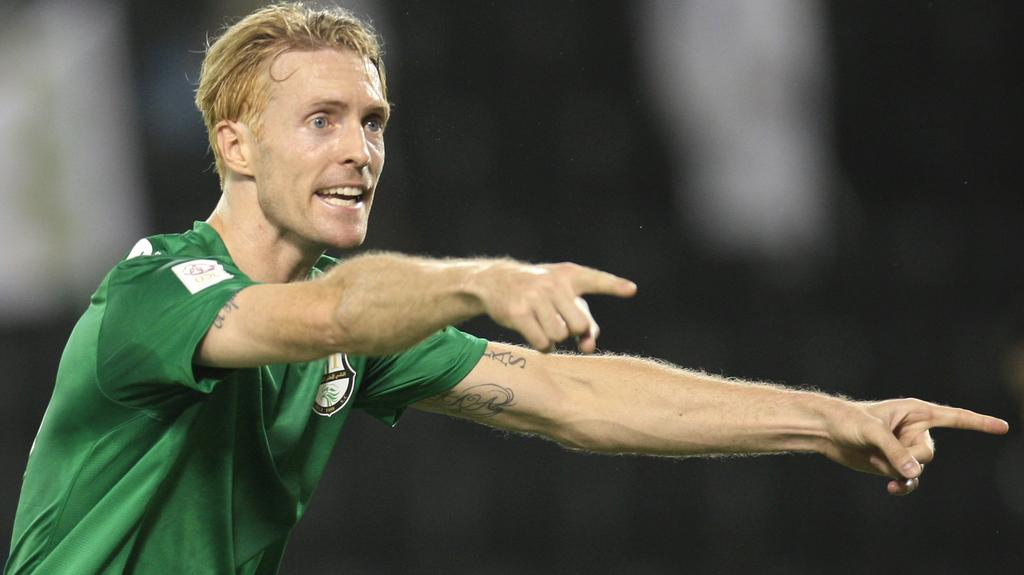What is present in the image? There is a person in the image. What is the person wearing? The person is wearing a green T-shirt. What type of music is the bat playing in the image? There is no bat or music present in the image; it only features a person wearing a green T-shirt. 